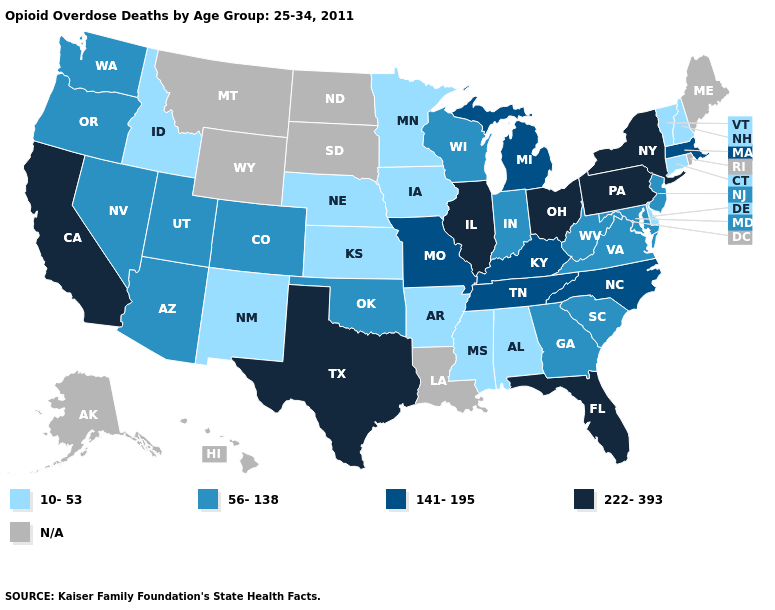How many symbols are there in the legend?
Keep it brief. 5. Among the states that border Nebraska , which have the lowest value?
Quick response, please. Iowa, Kansas. Which states hav the highest value in the West?
Write a very short answer. California. Does Kansas have the highest value in the USA?
Answer briefly. No. Does the map have missing data?
Keep it brief. Yes. What is the value of Texas?
Keep it brief. 222-393. What is the value of Washington?
Concise answer only. 56-138. What is the lowest value in the MidWest?
Concise answer only. 10-53. Name the states that have a value in the range 56-138?
Be succinct. Arizona, Colorado, Georgia, Indiana, Maryland, Nevada, New Jersey, Oklahoma, Oregon, South Carolina, Utah, Virginia, Washington, West Virginia, Wisconsin. Among the states that border Kentucky , which have the highest value?
Concise answer only. Illinois, Ohio. Does Ohio have the highest value in the USA?
Quick response, please. Yes. What is the value of New Jersey?
Give a very brief answer. 56-138. Name the states that have a value in the range 56-138?
Write a very short answer. Arizona, Colorado, Georgia, Indiana, Maryland, Nevada, New Jersey, Oklahoma, Oregon, South Carolina, Utah, Virginia, Washington, West Virginia, Wisconsin. Name the states that have a value in the range N/A?
Quick response, please. Alaska, Hawaii, Louisiana, Maine, Montana, North Dakota, Rhode Island, South Dakota, Wyoming. 